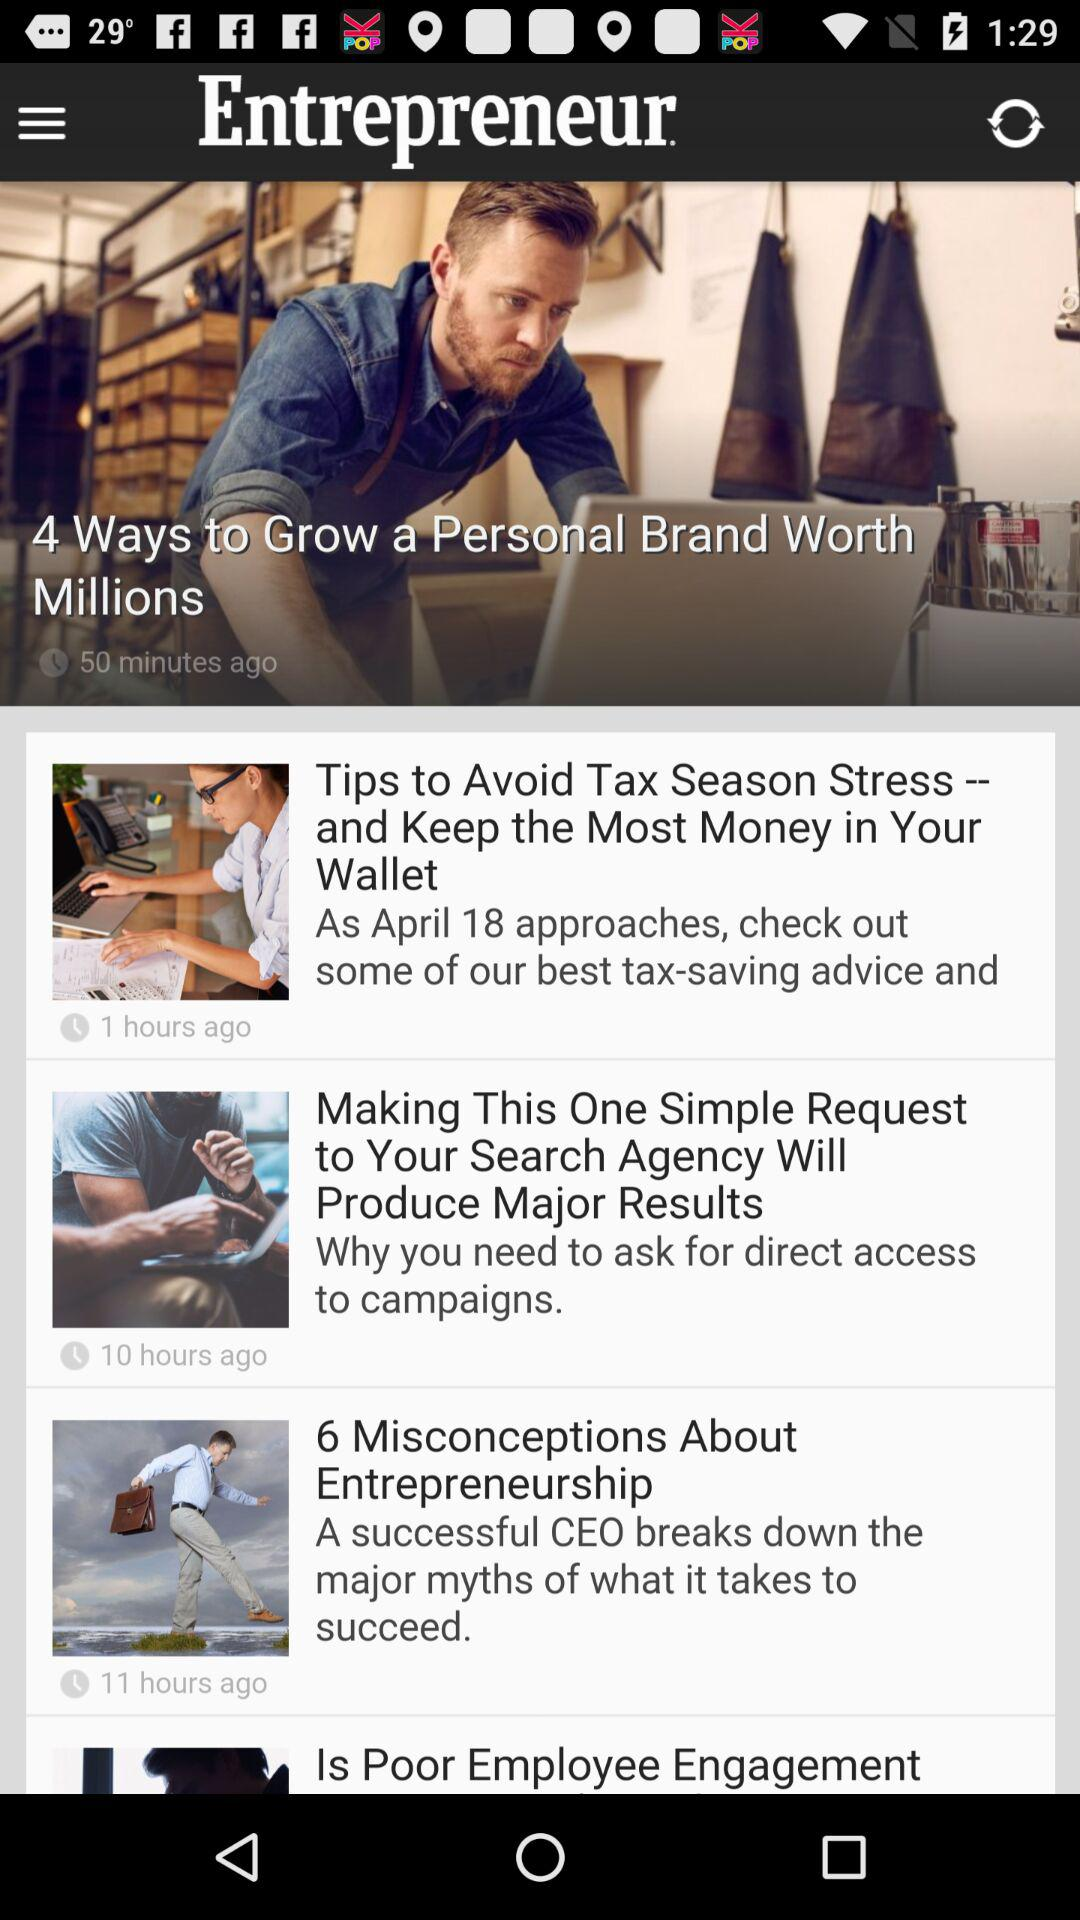When was the post titled "4 Ways to Grow a Personal Brand Worth Millions" posted? The post titled "4 Ways to Grow a Personal Brand Worth Millions" was posted 50 minutes ago. 